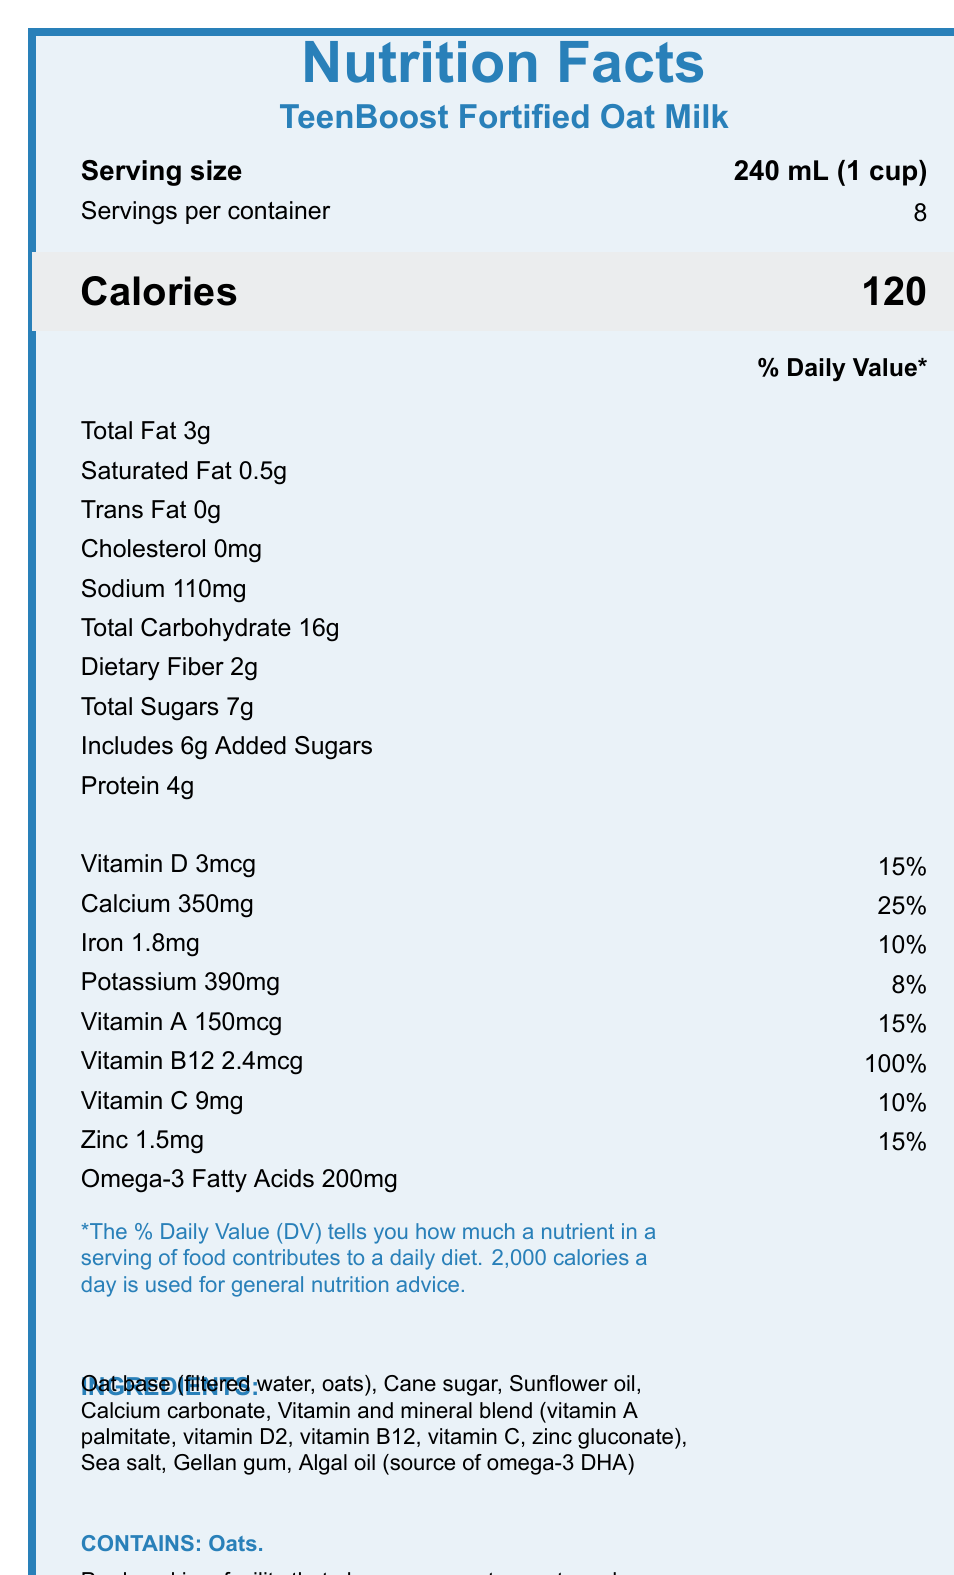what is the serving size for TeenBoost Fortified Oat Milk? The serving size is clearly mentioned at the top of the Nutrition Facts Label.
Answer: 240 mL (1 cup) how many servings are there per container? The number of servings per container is listed right below the serving size information.
Answer: 8 how many calories are there per serving? The calories per serving are stated clearly in large font under the calorie information section.
Answer: 120 how much total fat is in one serving and what is its percent daily value? The total fat amount and its corresponding percent daily value are both listed in the nutrient table.
Answer: 3g, 4% how much vitamin D is in one serving and what is its percent daily value? The vitamin D content and percent daily value are found in the vitamins and minerals section.
Answer: 3mcg, 15% how much omega-3 fatty acids does this product contain? The omega-3 fatty acids amount is mentioned at the bottom of the nutrients list.
Answer: 200mg how does TeenBoost Fortified Oat Milk compare to cow milk in terms of fat content? As detailed in the comparisonToCowMilk section, the fat content in TeenBoost Fortified Oat Milk is lower compared to cow milk.
Answer: Lower which of the following is an ingredient in TeenBoost Fortified Oat Milk? A. Coconut oil B. Sea salt C. Rice syrup The ingredients list includes sea salt.
Answer: B how much calcium is there per serving and what is its percent daily value? The calcium content and its percent daily value are stated in the vitamins and minerals section.
Answer: 350mg, 25% which vitamin present in this oat milk is 100% of the daily value? The vitamins and minerals section shows that vitamin B12 is listed with 100% of the daily value.
Answer: Vitamin B12 is this product suitable for someone with a nut allergy? It is produced in a facility that also processes tree nuts, making it potentially unsuitable for someone with a nut allergy.
Answer: No describe the main purpose and nutritional benefits of TeenBoost Fortified Oat Milk. The document provides a comprehensive nutritional profile showing how TeenBoost Fortified Oat Milk supports the growth and health of adolescents by including various nutrients.
Answer: TeenBoost Fortified Oat Milk is a fortified milk alternative designed to support the nutritional needs of growing adolescents. It is a good source of calcium and vitamin D for bone health, contains omega-3s for brain development, and includes essential vitamins like B12, iron, and vitamin C. what is the cholesterol content in TeenBoost Fortified Oat Milk? The nutrient table shows that the cholesterol content in this product is listed as 0mg.
Answer: 0mg how many grams of added sugars are there in one serving of TeenBoost Fortified Oat Milk? The nutrient table lists the added sugars amount specifically as 6g.
Answer: 6g what is not mentioned about the ingredients in TeenBoost Fortified Oat Milk? While the ingredients are listed, the specific proportion of each ingredient is not provided in the document.
Answer: The specific proportion of each ingredient 